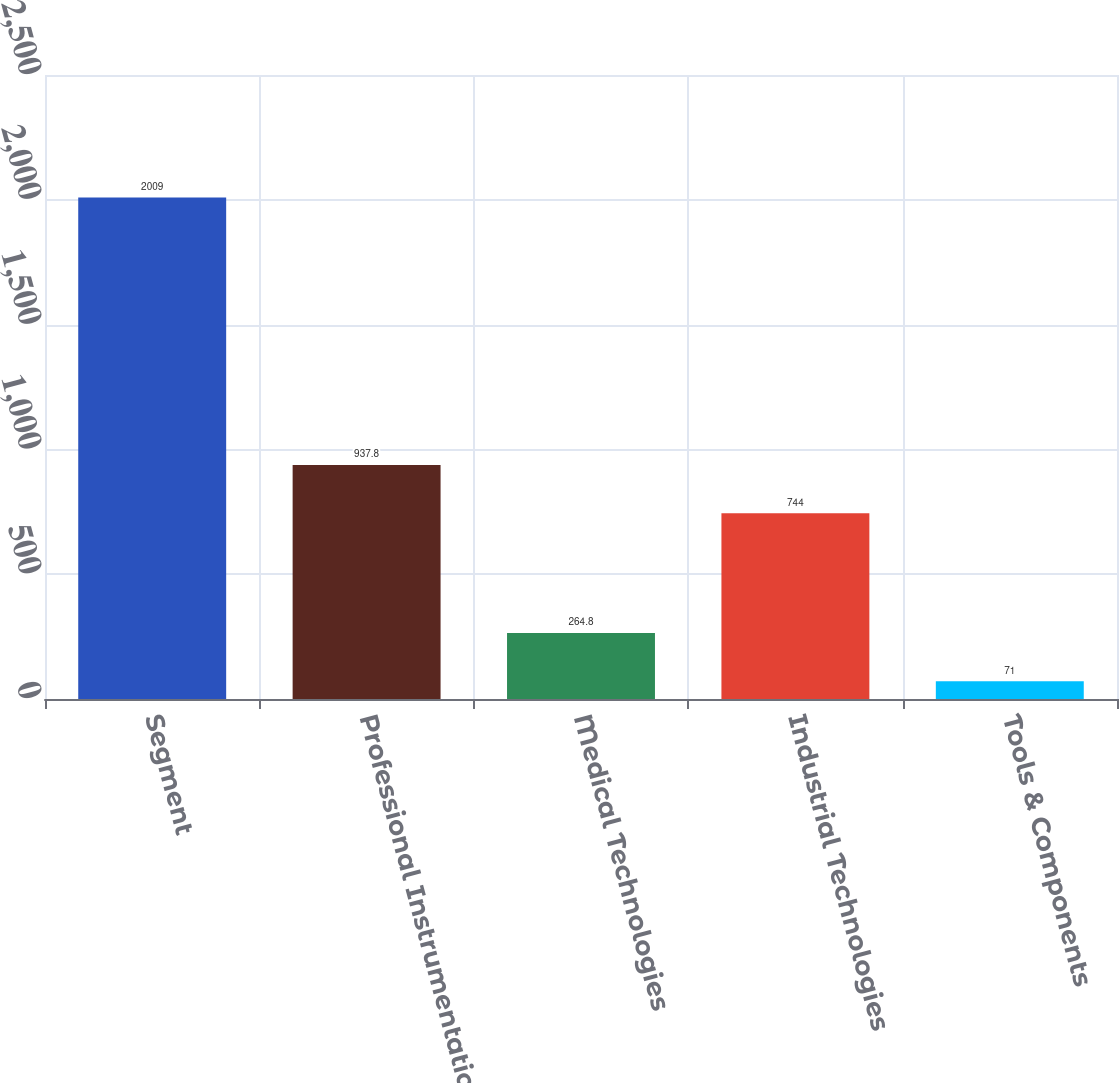<chart> <loc_0><loc_0><loc_500><loc_500><bar_chart><fcel>Segment<fcel>Professional Instrumentation<fcel>Medical Technologies<fcel>Industrial Technologies<fcel>Tools & Components<nl><fcel>2009<fcel>937.8<fcel>264.8<fcel>744<fcel>71<nl></chart> 